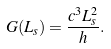<formula> <loc_0><loc_0><loc_500><loc_500>G ( L _ { s } ) = \frac { c ^ { 3 } L _ { s } ^ { 2 } } { h } .</formula> 